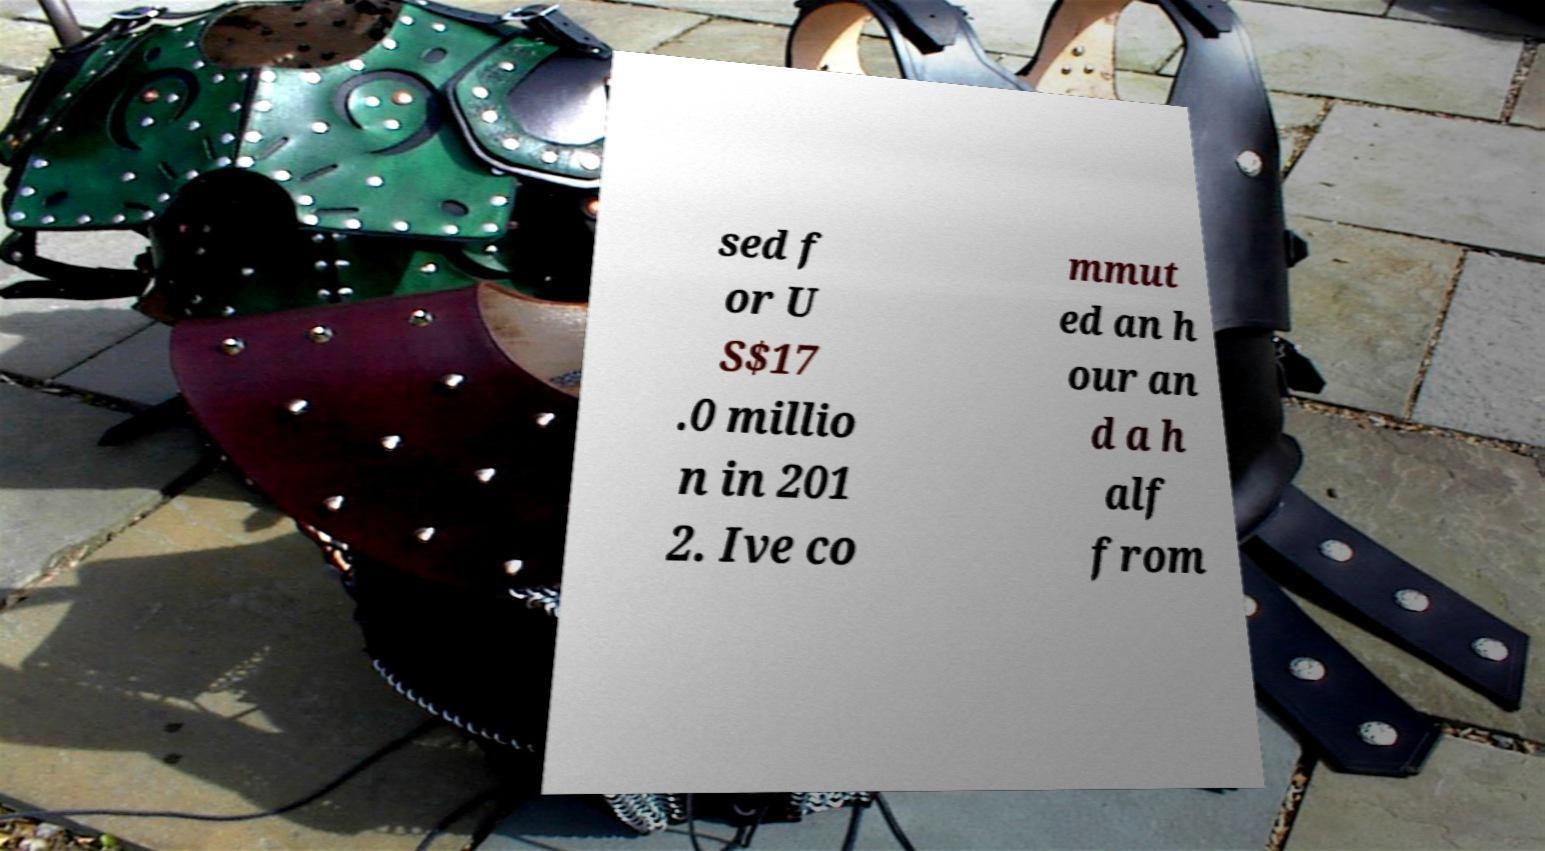Can you accurately transcribe the text from the provided image for me? sed f or U S$17 .0 millio n in 201 2. Ive co mmut ed an h our an d a h alf from 